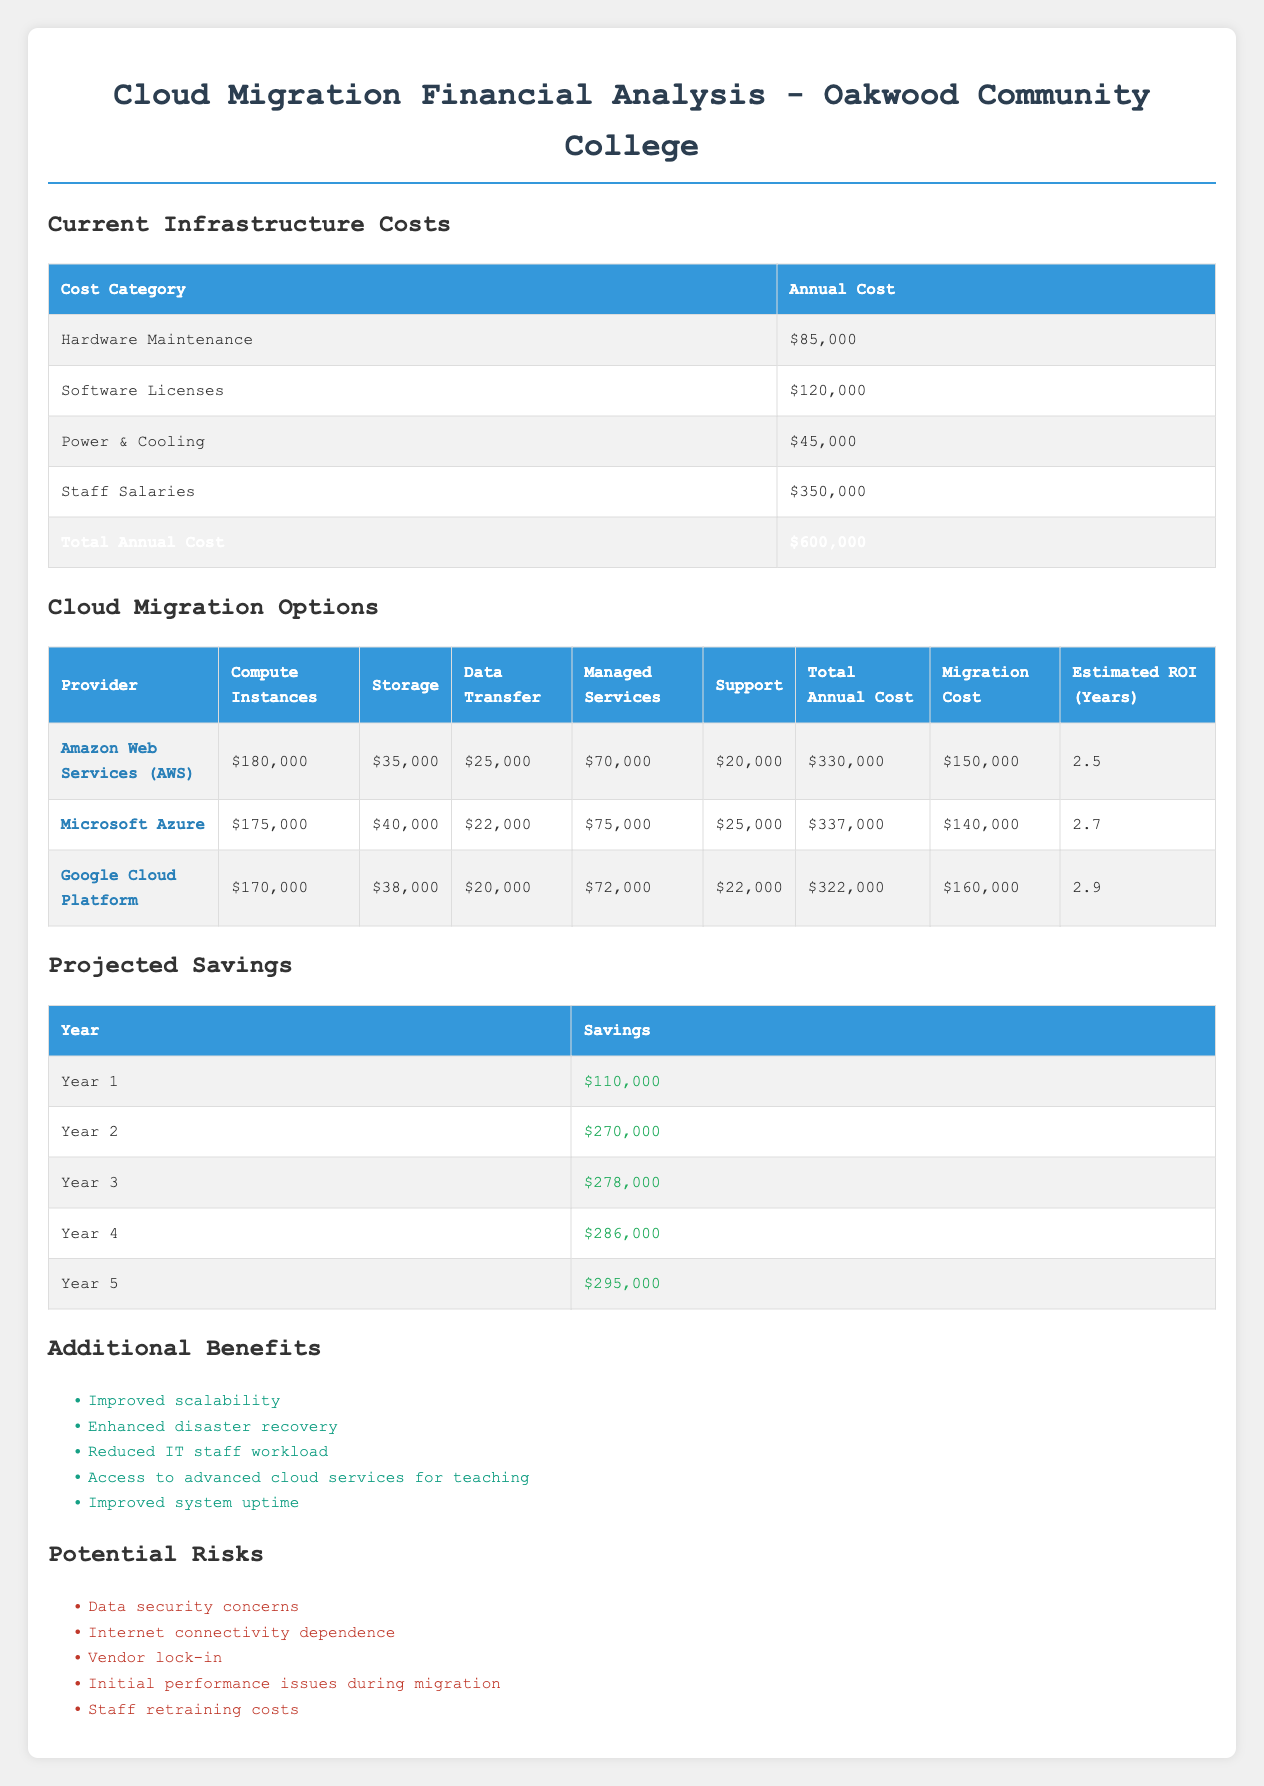What is the total annual cost of the current infrastructure? The total annual cost is listed in the current infrastructure section of the table. It shows a value of $600,000.
Answer: 600000 What is the migration cost for Google Cloud Platform? The migration cost for Google Cloud Platform is provided directly in the cloud migration options table, showing a value of $160,000.
Answer: 160000 Which cloud provider has the lowest total annual cost? By comparing the total annual costs from the cloud migration options table, Google Cloud Platform has the lowest total at $322,000.
Answer: Google Cloud Platform How much would Oakwood Community College save in the second year after migration? The projected savings for Year 2 is $270,000, which is taken directly from the projected savings table.
Answer: 270000 If we calculate the total projected savings over five years, what is the sum? The sum of projected savings is $110,000 + $270,000 + $278,000 + $286,000 + $295,000 = $1,239,000. The values are taken directly from the projected savings table.
Answer: 1239000 Is the estimated ROI for Microsoft Azure higher than for AWS? The estimated ROI for Microsoft Azure is 2.7 years and for AWS is 2.5 years. Since 2.7 is greater than 2.5, the statement is true.
Answer: Yes What is the difference in total annual cost between Microsoft Azure and Google Cloud Platform? The total annual cost for Microsoft Azure is $337,000 and for Google Cloud Platform is $322,000. The difference is $337,000 - $322,000 = $15,000.
Answer: 15000 What are the potential risks listed regarding cloud migration? The potential risks can be found in the risks section of the table: Data security concerns, Internet connectivity dependence, Vendor lock-in, Initial performance issues during migration, and Staff retraining costs.
Answer: Data security concerns, Internet connectivity dependence, Vendor lock-in, Initial performance issues during migration, Staff retraining costs How many more years would it take to see a return on investment with Google Cloud Platform compared to AWS? The estimated ROI for Google Cloud Platform is 2.9 years and for AWS is 2.5 years. The difference is 2.9 - 2.5 = 0.4 years.
Answer: 0.4 years 